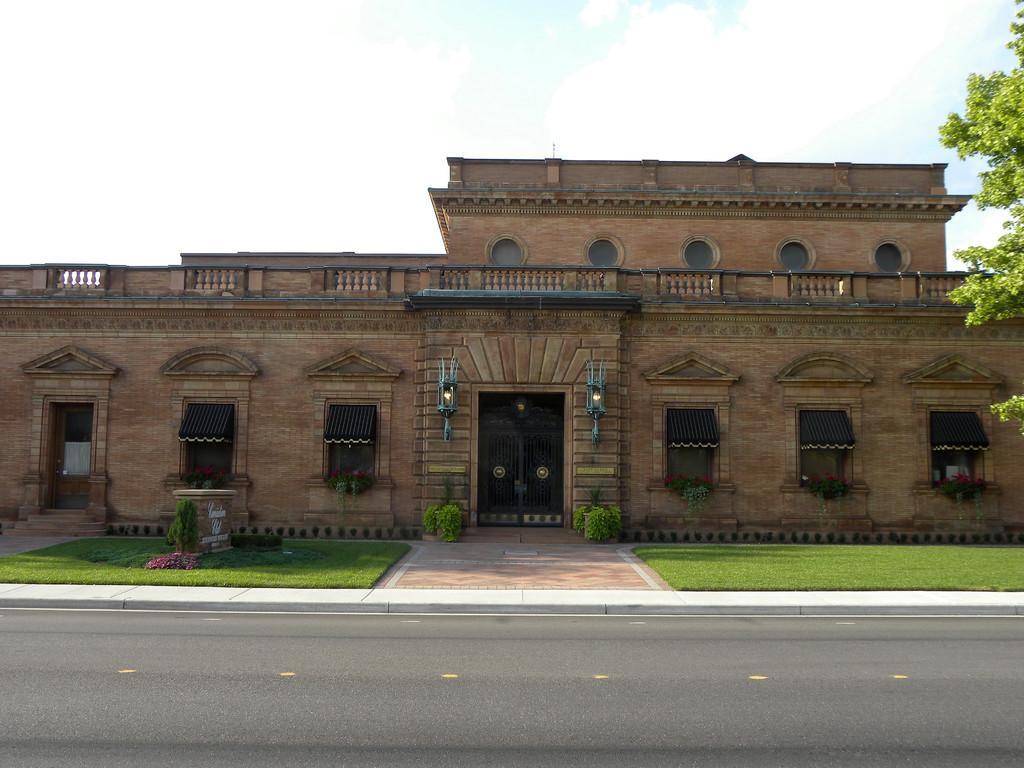What type of structure is in the image? There is a building in the image. What can be seen illuminating the area in the image? There are lights in the image. What type of vegetation is present in the image? Grass and plants are visible in the image. What type of tree is in the image? There is a tree in the image. What is visible in the background of the image? The sky is visible in the background of the image. What type of bed can be seen in the image? There is no bed present in the image. What is the carpenter working on in the image? There is no carpenter or any indication of carpentry work in the image. 